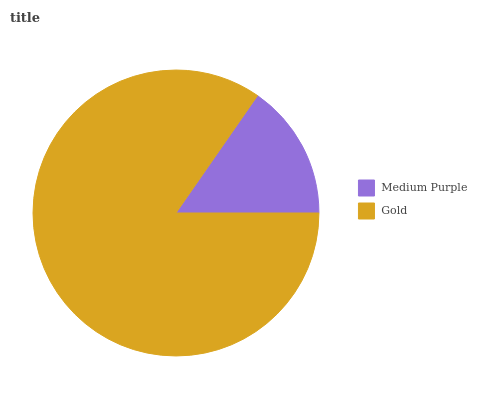Is Medium Purple the minimum?
Answer yes or no. Yes. Is Gold the maximum?
Answer yes or no. Yes. Is Gold the minimum?
Answer yes or no. No. Is Gold greater than Medium Purple?
Answer yes or no. Yes. Is Medium Purple less than Gold?
Answer yes or no. Yes. Is Medium Purple greater than Gold?
Answer yes or no. No. Is Gold less than Medium Purple?
Answer yes or no. No. Is Gold the high median?
Answer yes or no. Yes. Is Medium Purple the low median?
Answer yes or no. Yes. Is Medium Purple the high median?
Answer yes or no. No. Is Gold the low median?
Answer yes or no. No. 